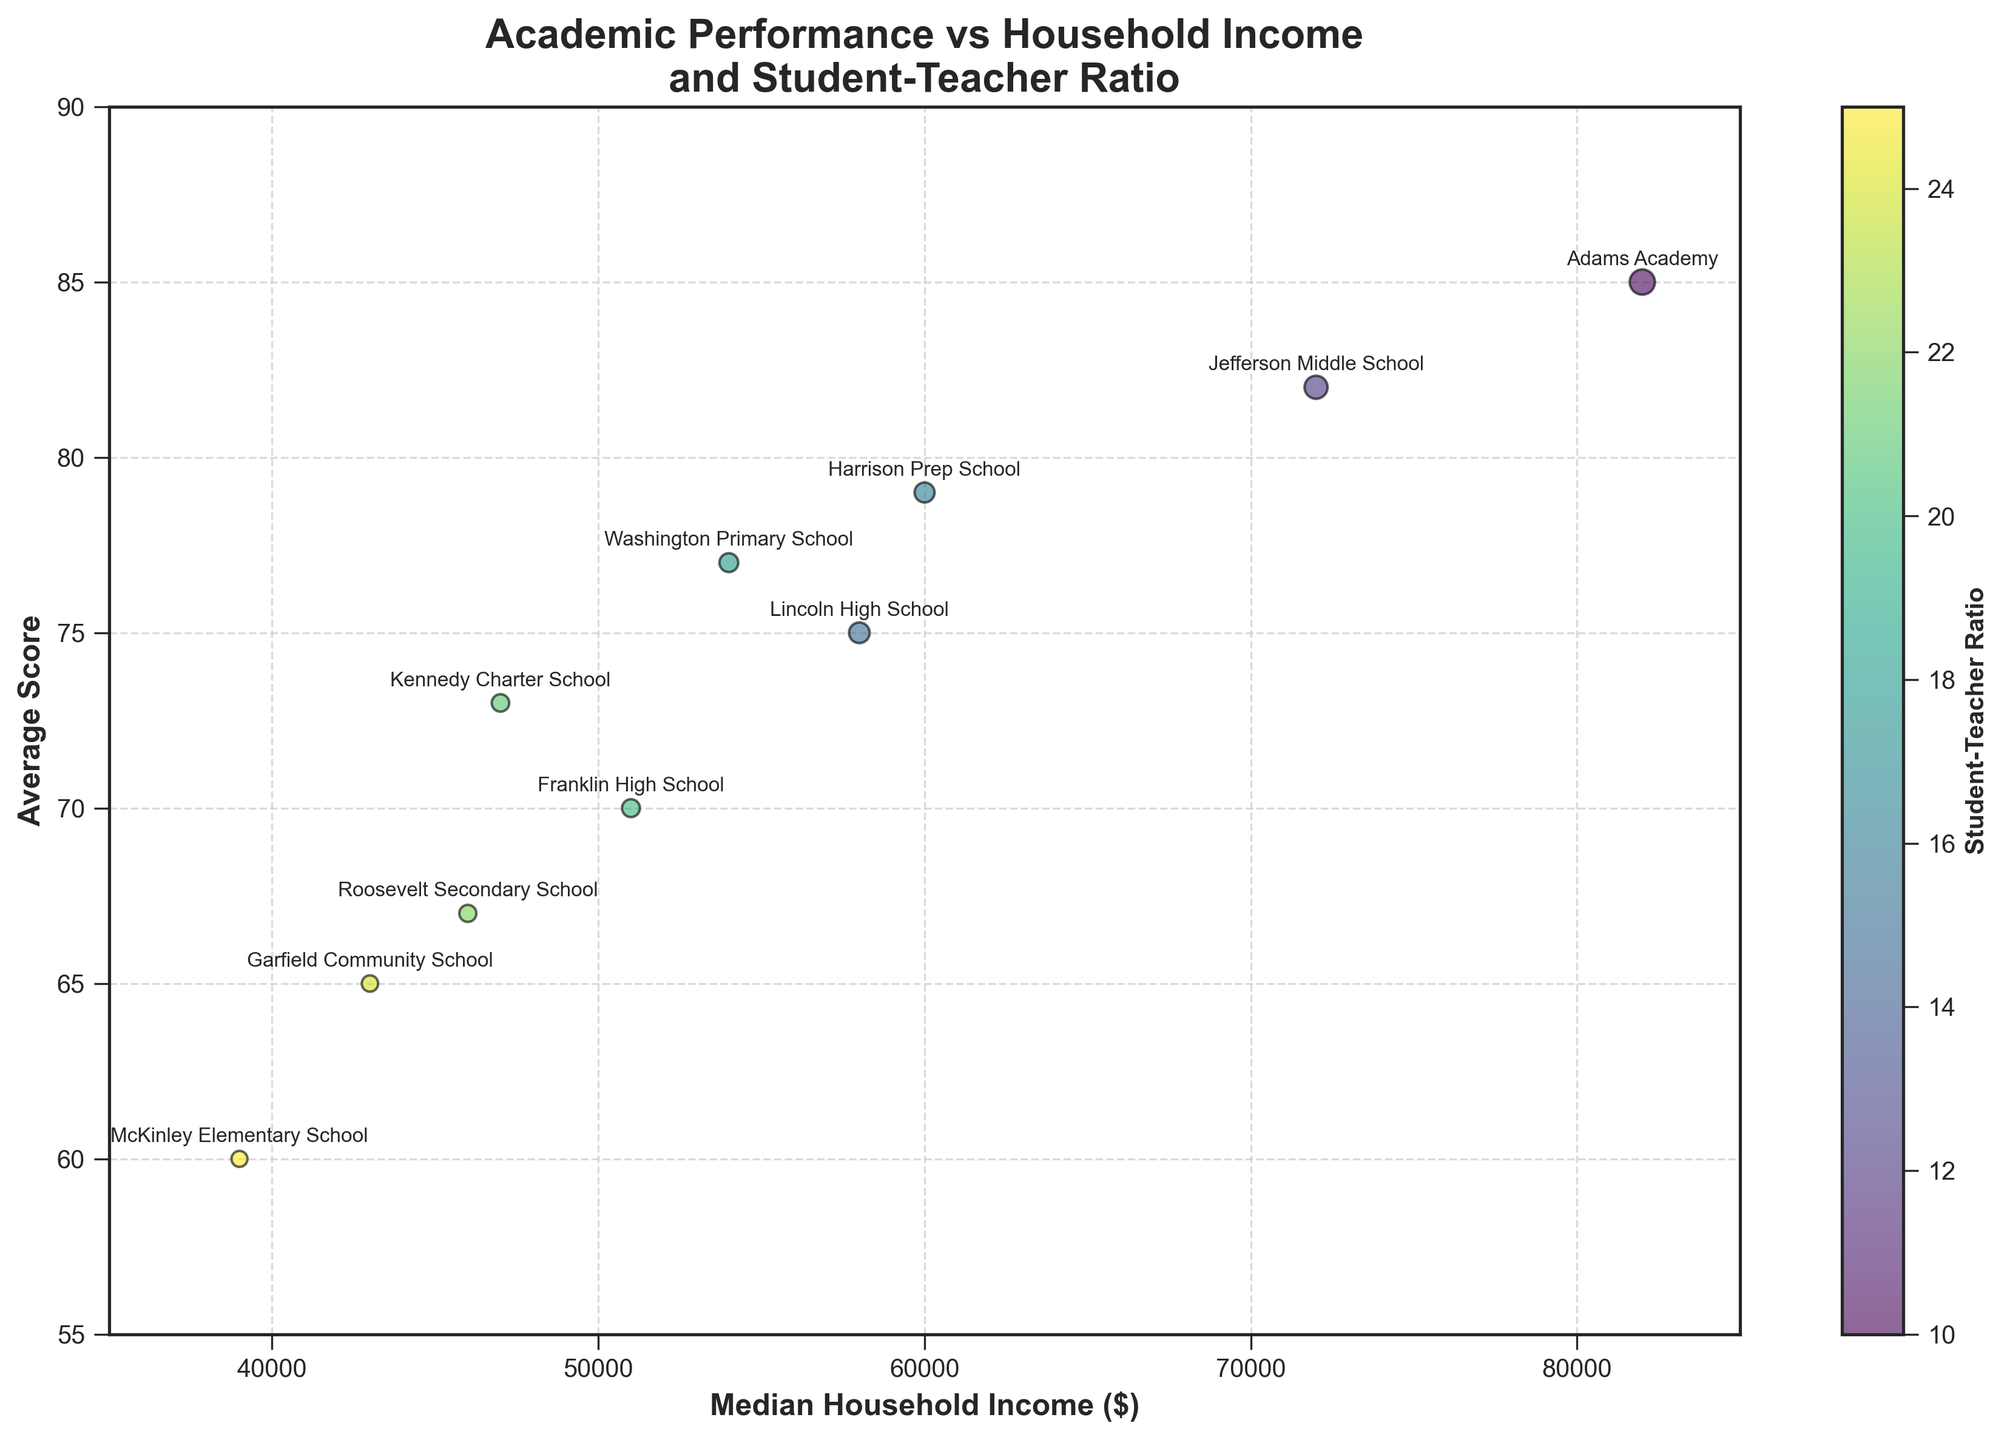What is the title of the graph? The title of the graph is displayed at the top and reads "Academic Performance vs Household Income and Student-Teacher Ratio".
Answer: Academic Performance vs Household Income and Student-Teacher Ratio Which school has the highest average score? The school with the highest average score can be identified by the highest vertical position. Adams Academy at 85 has the highest average score.
Answer: Adams Academy Which colors represent the Student-Teacher Ratios? The color bar labeled 'Student-Teacher Ratio' on the right side of the graph uses a viridis colormap, ranging from blue for lower ratios to yellow for higher ratios.
Answer: Blue to yellow How many schools have an average score above 75? Schools with an average score above 75 can be identified by their position above the 75 mark on the y-axis. There are 5 such schools: Lincoln High School, Jefferson Middle School, Washington Primary School, Adams Academy, and Harrison Prep School.
Answer: 5 What is the range of Median Household Income displayed on the graph? The range of Median Household Income is indicated by the x-axis limits, which span from 35,000 to 85,000 dollars.
Answer: 35,000 to 85,000 dollars Which school has the smallest bubble size? The bubble size is inversely related to the Student-Teacher Ratio. The smallest bubble corresponds to McKinley Elementary School, which has a Student-Teacher Ratio of 25.
Answer: McKinley Elementary School Do schools with higher Median Household Income generally have higher average scores? By observing the scatter plot, schools with higher Median Household Income (towards the right on the x-axis) have higher average scores (higher on the y-axis), though this relationship is not perfect.
Answer: Yes, generally What student-teacher ratio corresponds to the largest bubble size? The largest bubbles represent the smallest student-teacher ratios. The bubble for Adams Academy has the largest size, corresponding to a ratio of 10.
Answer: 10 Compare the average scores of Lincoln High School and Garfield Community School. Lincoln High School has an average score of 75, while Garfield Community School has an average score of 65. Lincoln High School’s score is higher by 10 points.
Answer: Lincoln High School by 10 points Which school has a Median Household Income closest to 50,000 dollars and what is its average score? By looking at the x-axis, Franklin High School has a Median Household Income closest to 50,000 dollars and its average score is 70.
Answer: Franklin High School, 70 